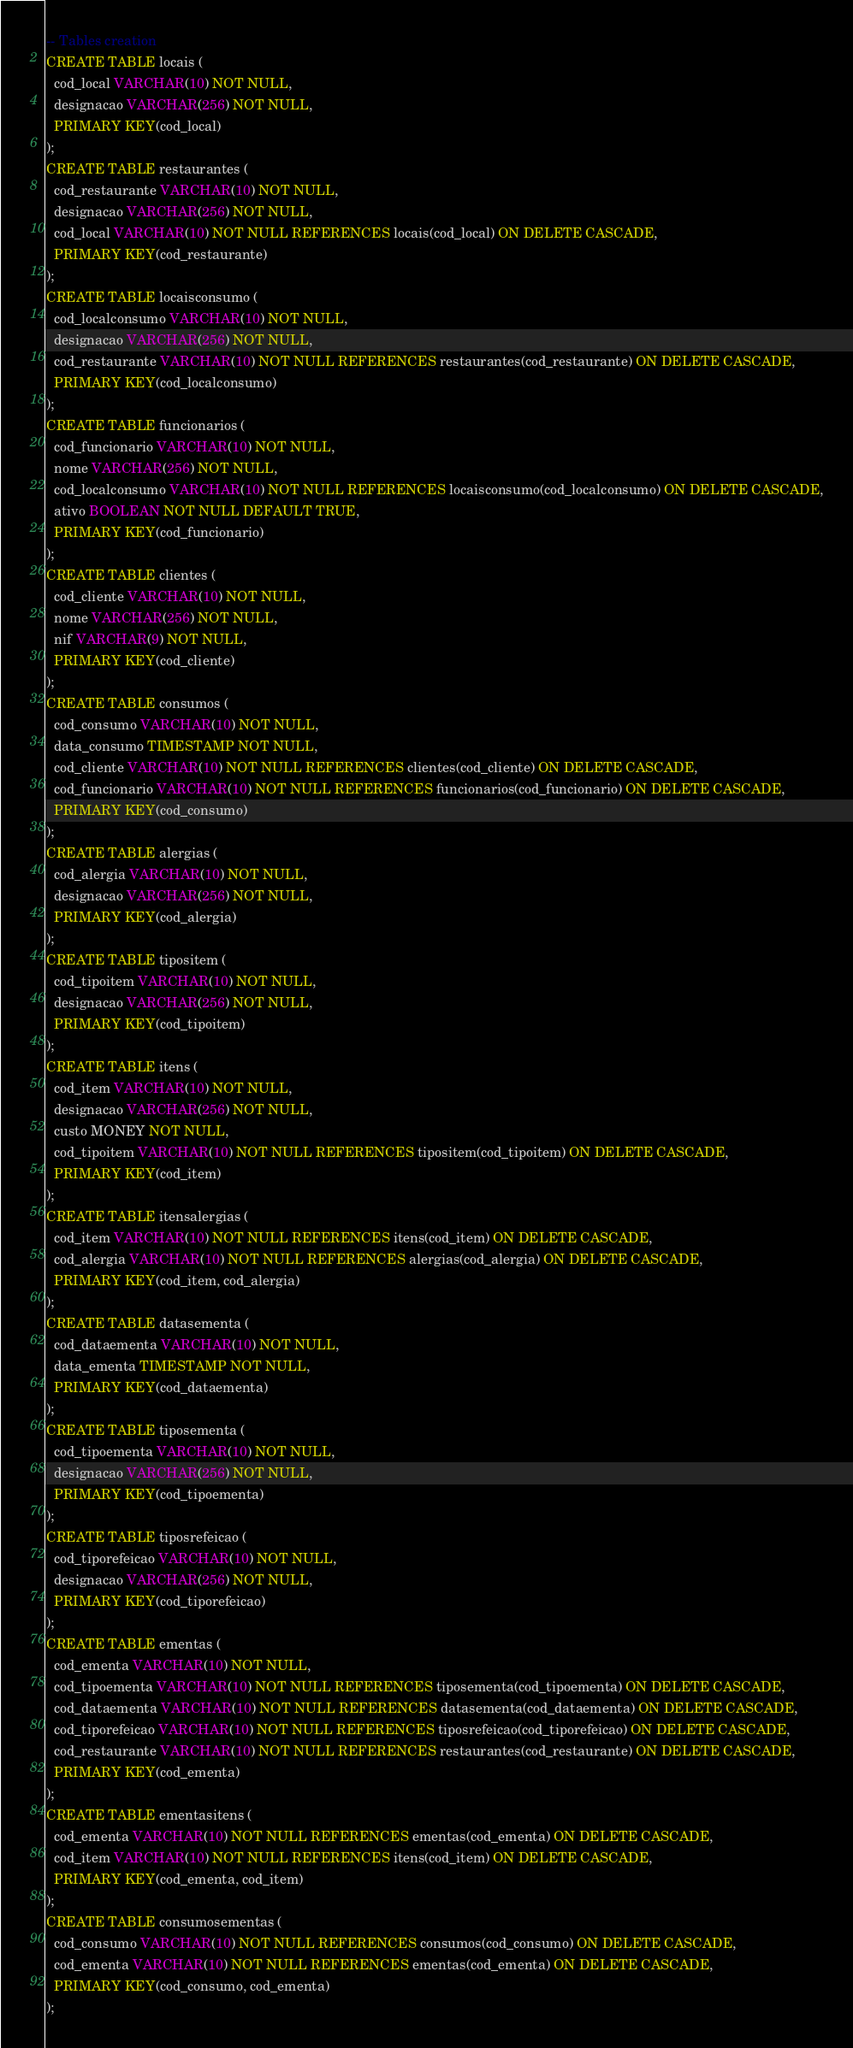Convert code to text. <code><loc_0><loc_0><loc_500><loc_500><_SQL_>-- Tables creation
CREATE TABLE locais (
  cod_local VARCHAR(10) NOT NULL,
  designacao VARCHAR(256) NOT NULL,
  PRIMARY KEY(cod_local)
);
CREATE TABLE restaurantes (
  cod_restaurante VARCHAR(10) NOT NULL,
  designacao VARCHAR(256) NOT NULL,
  cod_local VARCHAR(10) NOT NULL REFERENCES locais(cod_local) ON DELETE CASCADE,
  PRIMARY KEY(cod_restaurante)
);
CREATE TABLE locaisconsumo (
  cod_localconsumo VARCHAR(10) NOT NULL,
  designacao VARCHAR(256) NOT NULL,
  cod_restaurante VARCHAR(10) NOT NULL REFERENCES restaurantes(cod_restaurante) ON DELETE CASCADE,
  PRIMARY KEY(cod_localconsumo)
);
CREATE TABLE funcionarios (
  cod_funcionario VARCHAR(10) NOT NULL,
  nome VARCHAR(256) NOT NULL,
  cod_localconsumo VARCHAR(10) NOT NULL REFERENCES locaisconsumo(cod_localconsumo) ON DELETE CASCADE,
  ativo BOOLEAN NOT NULL DEFAULT TRUE, 
  PRIMARY KEY(cod_funcionario)
);
CREATE TABLE clientes (
  cod_cliente VARCHAR(10) NOT NULL,
  nome VARCHAR(256) NOT NULL,
  nif VARCHAR(9) NOT NULL,
  PRIMARY KEY(cod_cliente)
);
CREATE TABLE consumos (
  cod_consumo VARCHAR(10) NOT NULL,
  data_consumo TIMESTAMP NOT NULL,
  cod_cliente VARCHAR(10) NOT NULL REFERENCES clientes(cod_cliente) ON DELETE CASCADE,
  cod_funcionario VARCHAR(10) NOT NULL REFERENCES funcionarios(cod_funcionario) ON DELETE CASCADE,
  PRIMARY KEY(cod_consumo)
);
CREATE TABLE alergias (
  cod_alergia VARCHAR(10) NOT NULL,
  designacao VARCHAR(256) NOT NULL,
  PRIMARY KEY(cod_alergia)
);
CREATE TABLE tipositem (
  cod_tipoitem VARCHAR(10) NOT NULL,
  designacao VARCHAR(256) NOT NULL,
  PRIMARY KEY(cod_tipoitem)
);
CREATE TABLE itens (
  cod_item VARCHAR(10) NOT NULL,
  designacao VARCHAR(256) NOT NULL,
  custo MONEY NOT NULL,
  cod_tipoitem VARCHAR(10) NOT NULL REFERENCES tipositem(cod_tipoitem) ON DELETE CASCADE,
  PRIMARY KEY(cod_item)
);
CREATE TABLE itensalergias (
  cod_item VARCHAR(10) NOT NULL REFERENCES itens(cod_item) ON DELETE CASCADE,
  cod_alergia VARCHAR(10) NOT NULL REFERENCES alergias(cod_alergia) ON DELETE CASCADE,
  PRIMARY KEY(cod_item, cod_alergia)
);
CREATE TABLE datasementa (
  cod_dataementa VARCHAR(10) NOT NULL,
  data_ementa TIMESTAMP NOT NULL,
  PRIMARY KEY(cod_dataementa)
);
CREATE TABLE tiposementa (
  cod_tipoementa VARCHAR(10) NOT NULL,
  designacao VARCHAR(256) NOT NULL,
  PRIMARY KEY(cod_tipoementa)
);
CREATE TABLE tiposrefeicao (
  cod_tiporefeicao VARCHAR(10) NOT NULL,
  designacao VARCHAR(256) NOT NULL,
  PRIMARY KEY(cod_tiporefeicao)
);
CREATE TABLE ementas (
  cod_ementa VARCHAR(10) NOT NULL,
  cod_tipoementa VARCHAR(10) NOT NULL REFERENCES tiposementa(cod_tipoementa) ON DELETE CASCADE,
  cod_dataementa VARCHAR(10) NOT NULL REFERENCES datasementa(cod_dataementa) ON DELETE CASCADE,
  cod_tiporefeicao VARCHAR(10) NOT NULL REFERENCES tiposrefeicao(cod_tiporefeicao) ON DELETE CASCADE,
  cod_restaurante VARCHAR(10) NOT NULL REFERENCES restaurantes(cod_restaurante) ON DELETE CASCADE,
  PRIMARY KEY(cod_ementa)
);
CREATE TABLE ementasitens (
  cod_ementa VARCHAR(10) NOT NULL REFERENCES ementas(cod_ementa) ON DELETE CASCADE,
  cod_item VARCHAR(10) NOT NULL REFERENCES itens(cod_item) ON DELETE CASCADE,
  PRIMARY KEY(cod_ementa, cod_item)
);
CREATE TABLE consumosementas (
  cod_consumo VARCHAR(10) NOT NULL REFERENCES consumos(cod_consumo) ON DELETE CASCADE,
  cod_ementa VARCHAR(10) NOT NULL REFERENCES ementas(cod_ementa) ON DELETE CASCADE,
  PRIMARY KEY(cod_consumo, cod_ementa)
);
</code> 